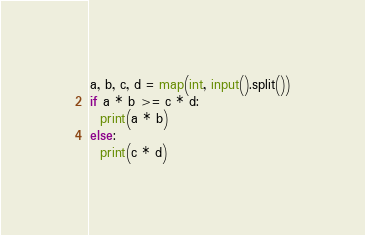Convert code to text. <code><loc_0><loc_0><loc_500><loc_500><_Python_>a, b, c, d = map(int, input().split())
if a * b >= c * d:
  print(a * b)
else:
  print(c * d)</code> 